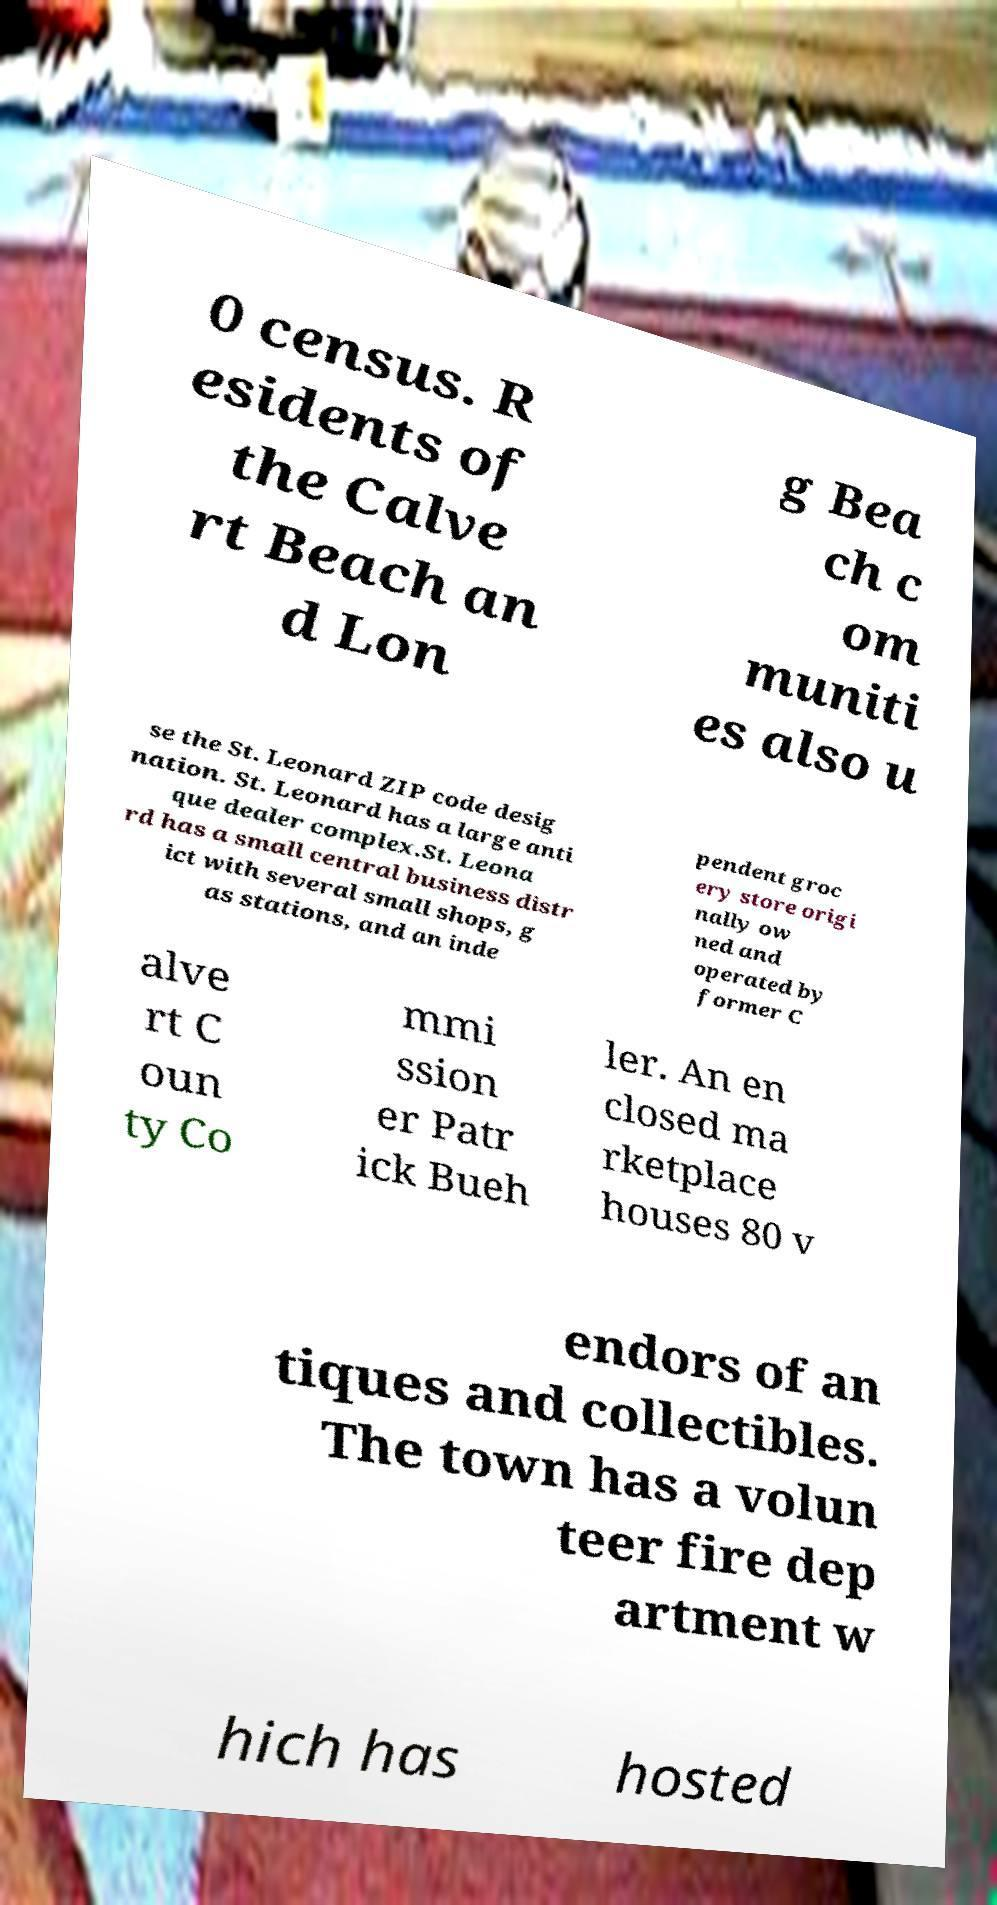For documentation purposes, I need the text within this image transcribed. Could you provide that? 0 census. R esidents of the Calve rt Beach an d Lon g Bea ch c om muniti es also u se the St. Leonard ZIP code desig nation. St. Leonard has a large anti que dealer complex.St. Leona rd has a small central business distr ict with several small shops, g as stations, and an inde pendent groc ery store origi nally ow ned and operated by former C alve rt C oun ty Co mmi ssion er Patr ick Bueh ler. An en closed ma rketplace houses 80 v endors of an tiques and collectibles. The town has a volun teer fire dep artment w hich has hosted 